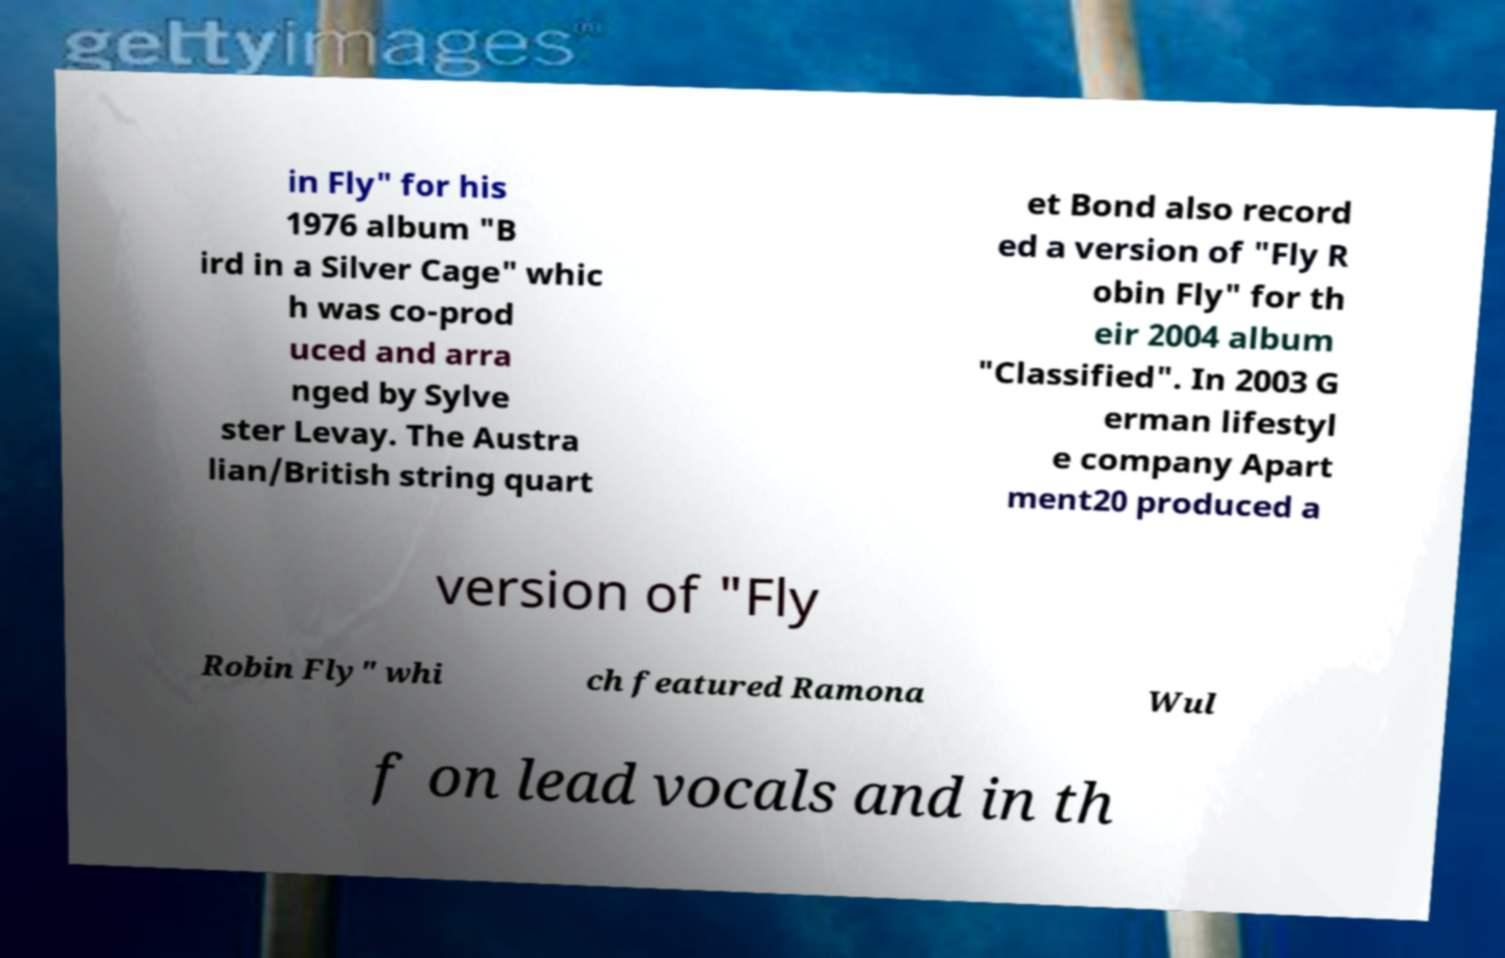Please read and relay the text visible in this image. What does it say? in Fly" for his 1976 album "B ird in a Silver Cage" whic h was co-prod uced and arra nged by Sylve ster Levay. The Austra lian/British string quart et Bond also record ed a version of "Fly R obin Fly" for th eir 2004 album "Classified". In 2003 G erman lifestyl e company Apart ment20 produced a version of "Fly Robin Fly" whi ch featured Ramona Wul f on lead vocals and in th 